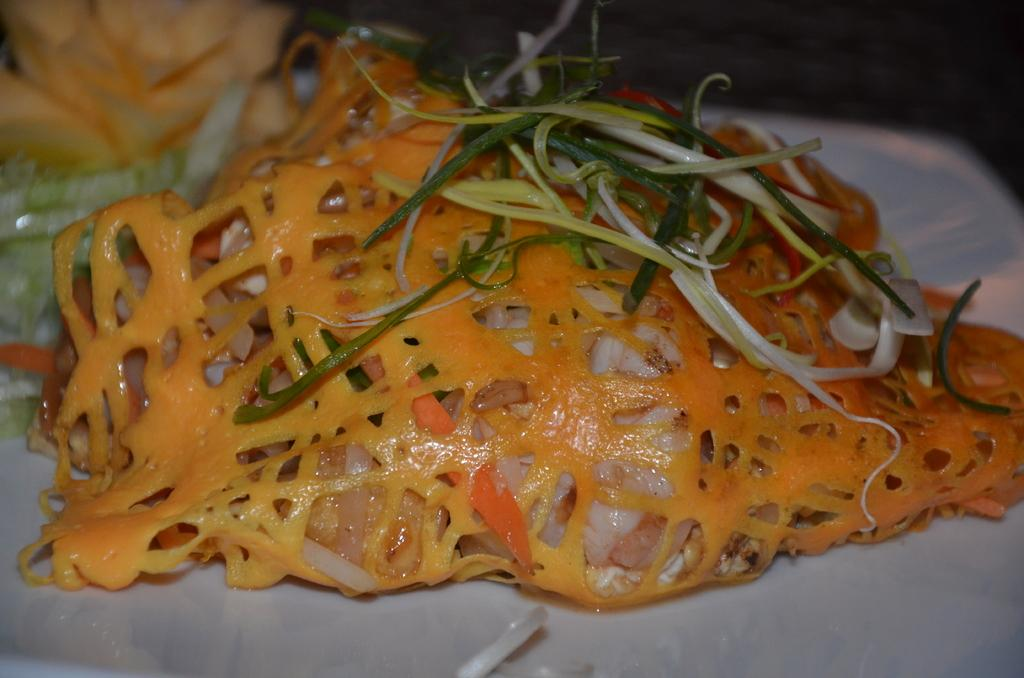What is the main food item visible on the plate in the image? The specific food item cannot be determined from the provided facts. What utensil is placed beside the plate in the image? There is a spoon beside the plate in the image. Where is the bat sleeping in the image? There is no bat present in the image. What type of truck is parked near the plate in the image? There is no truck present in the image. 